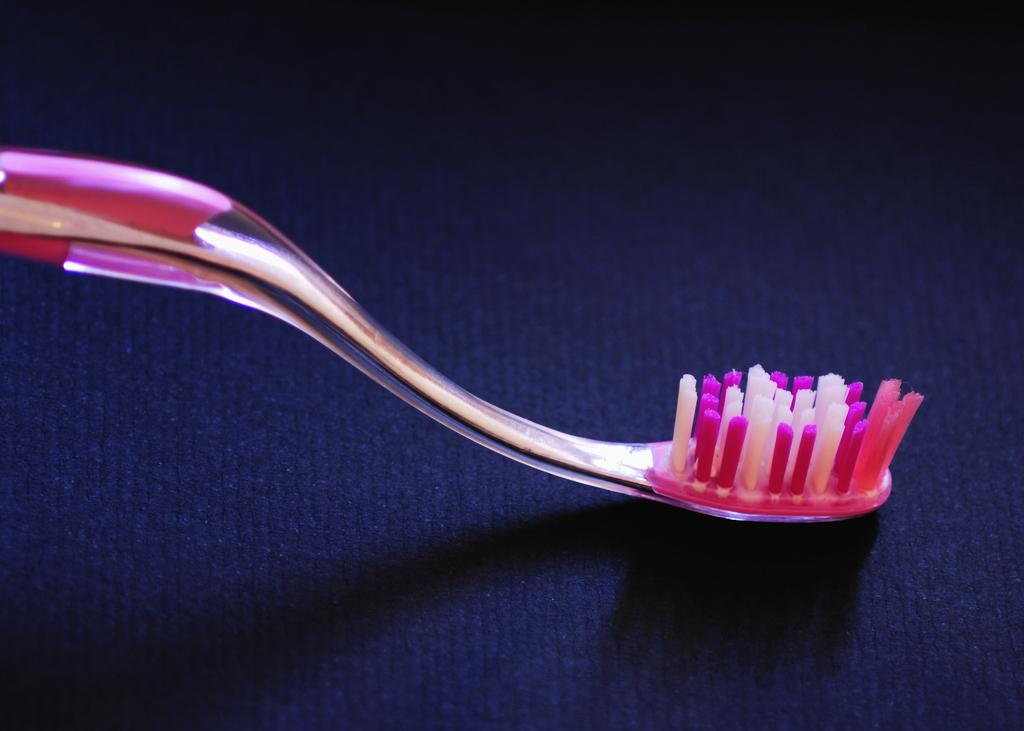What is the main object in the center of the image? There is a toothbrush in the center of the image. What type of flooring is visible at the bottom of the image? There is a blue carpet at the bottom of the image. How many quarters are stacked on top of the toothbrush in the image? There are no quarters present in the image; it only features a toothbrush and a blue carpet. 